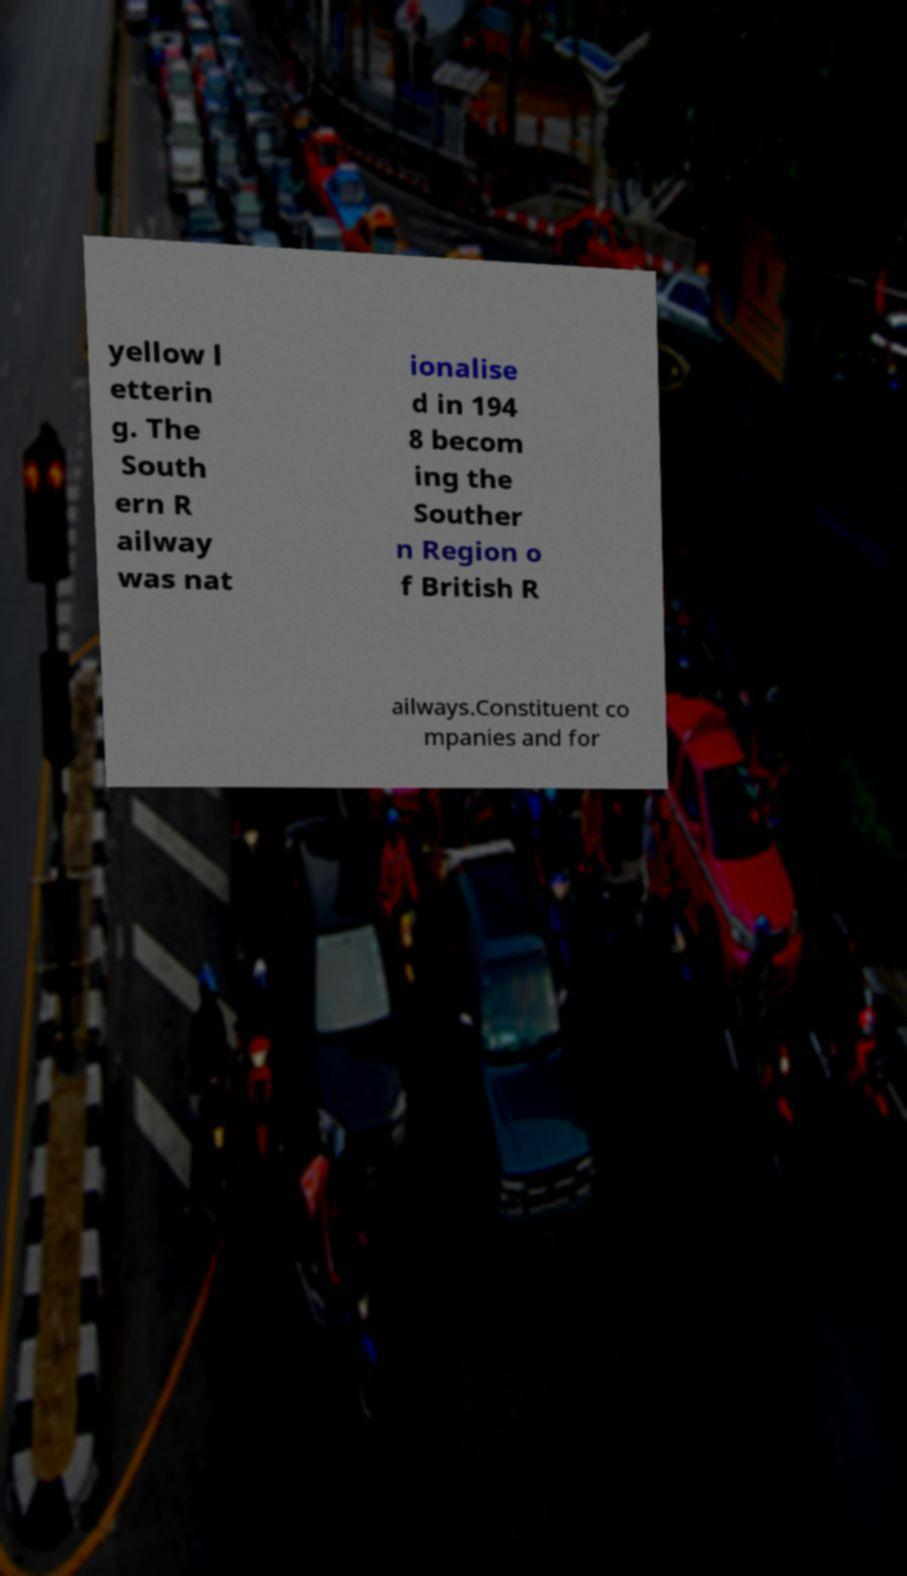Can you accurately transcribe the text from the provided image for me? yellow l etterin g. The South ern R ailway was nat ionalise d in 194 8 becom ing the Souther n Region o f British R ailways.Constituent co mpanies and for 